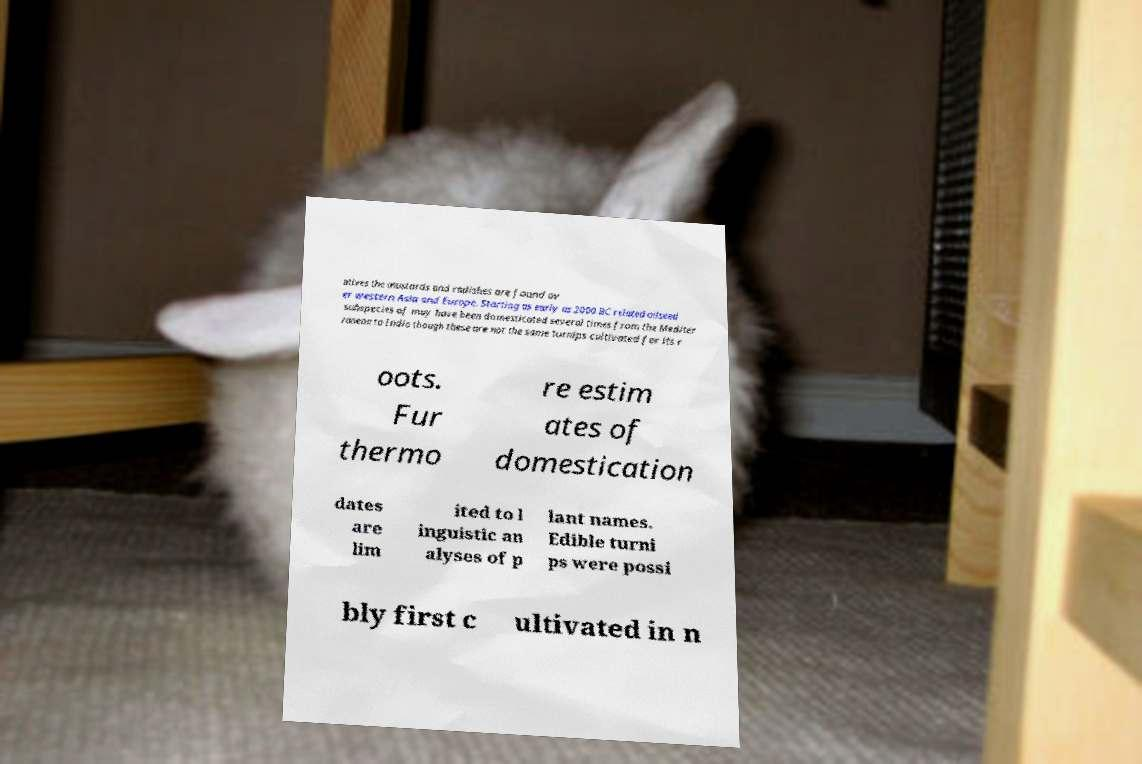I need the written content from this picture converted into text. Can you do that? atives the mustards and radishes are found ov er western Asia and Europe. Starting as early as 2000 BC related oilseed subspecies of may have been domesticated several times from the Mediter ranean to India though these are not the same turnips cultivated for its r oots. Fur thermo re estim ates of domestication dates are lim ited to l inguistic an alyses of p lant names. Edible turni ps were possi bly first c ultivated in n 